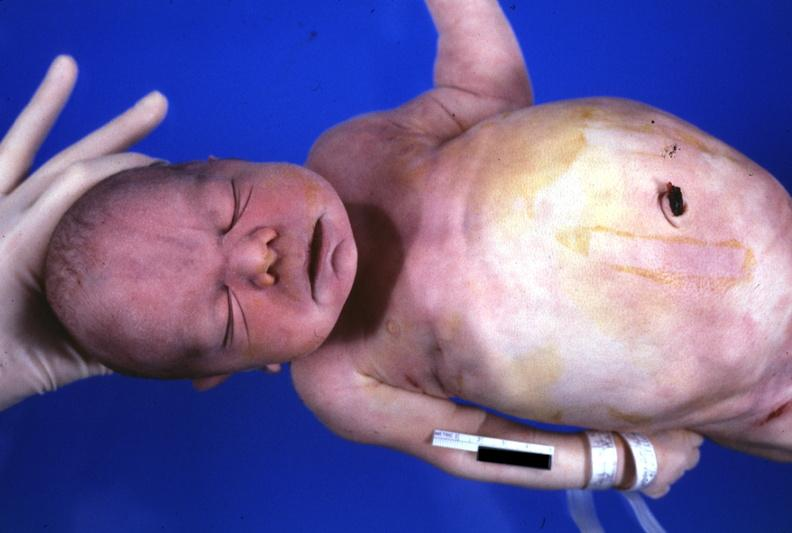s normal palmar creases present?
Answer the question using a single word or phrase. No 